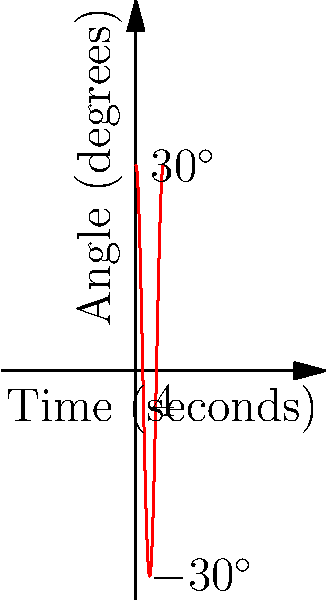A traditional Japanese clock (wadokei) uses a pendulum that swings back and forth. The angle of the pendulum from its rest position can be modeled by the function $\theta(t) = 30\cos(\frac{\pi}{2}t)$, where $\theta$ is the angle in degrees and $t$ is the time in seconds. What is the period of the pendulum's oscillation? To find the period of the pendulum's oscillation, we need to follow these steps:

1) The period of a cosine function is given by the formula:
   $T = \frac{2\pi}{|\omega|}$

   where $\omega$ is the angular frequency.

2) In our function $\theta(t) = 30\cos(\frac{\pi}{2}t)$, we can identify that:
   $\omega = \frac{\pi}{2}$

3) Substituting this into our period formula:
   $T = \frac{2\pi}{|\frac{\pi}{2}|}$

4) Simplify:
   $T = \frac{2\pi}{\frac{\pi}{2}} = 2\pi \cdot \frac{2}{\pi} = 4$

Therefore, the period of the pendulum's oscillation is 4 seconds.
Answer: 4 seconds 